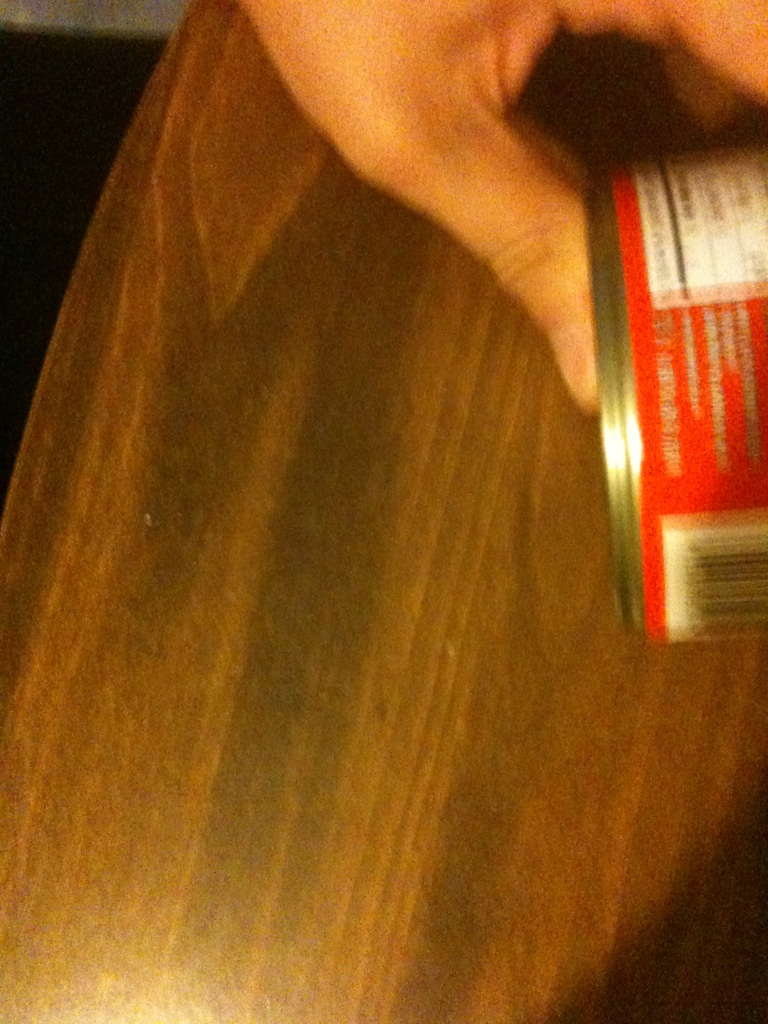What is this? from Vizwiz The image is blurry and makes it difficult to clearly identify the object. However, it appears to be a can, possibly a food item, as part of a label is visible. Due to the image quality, detailed identification cannot be confidently made. 